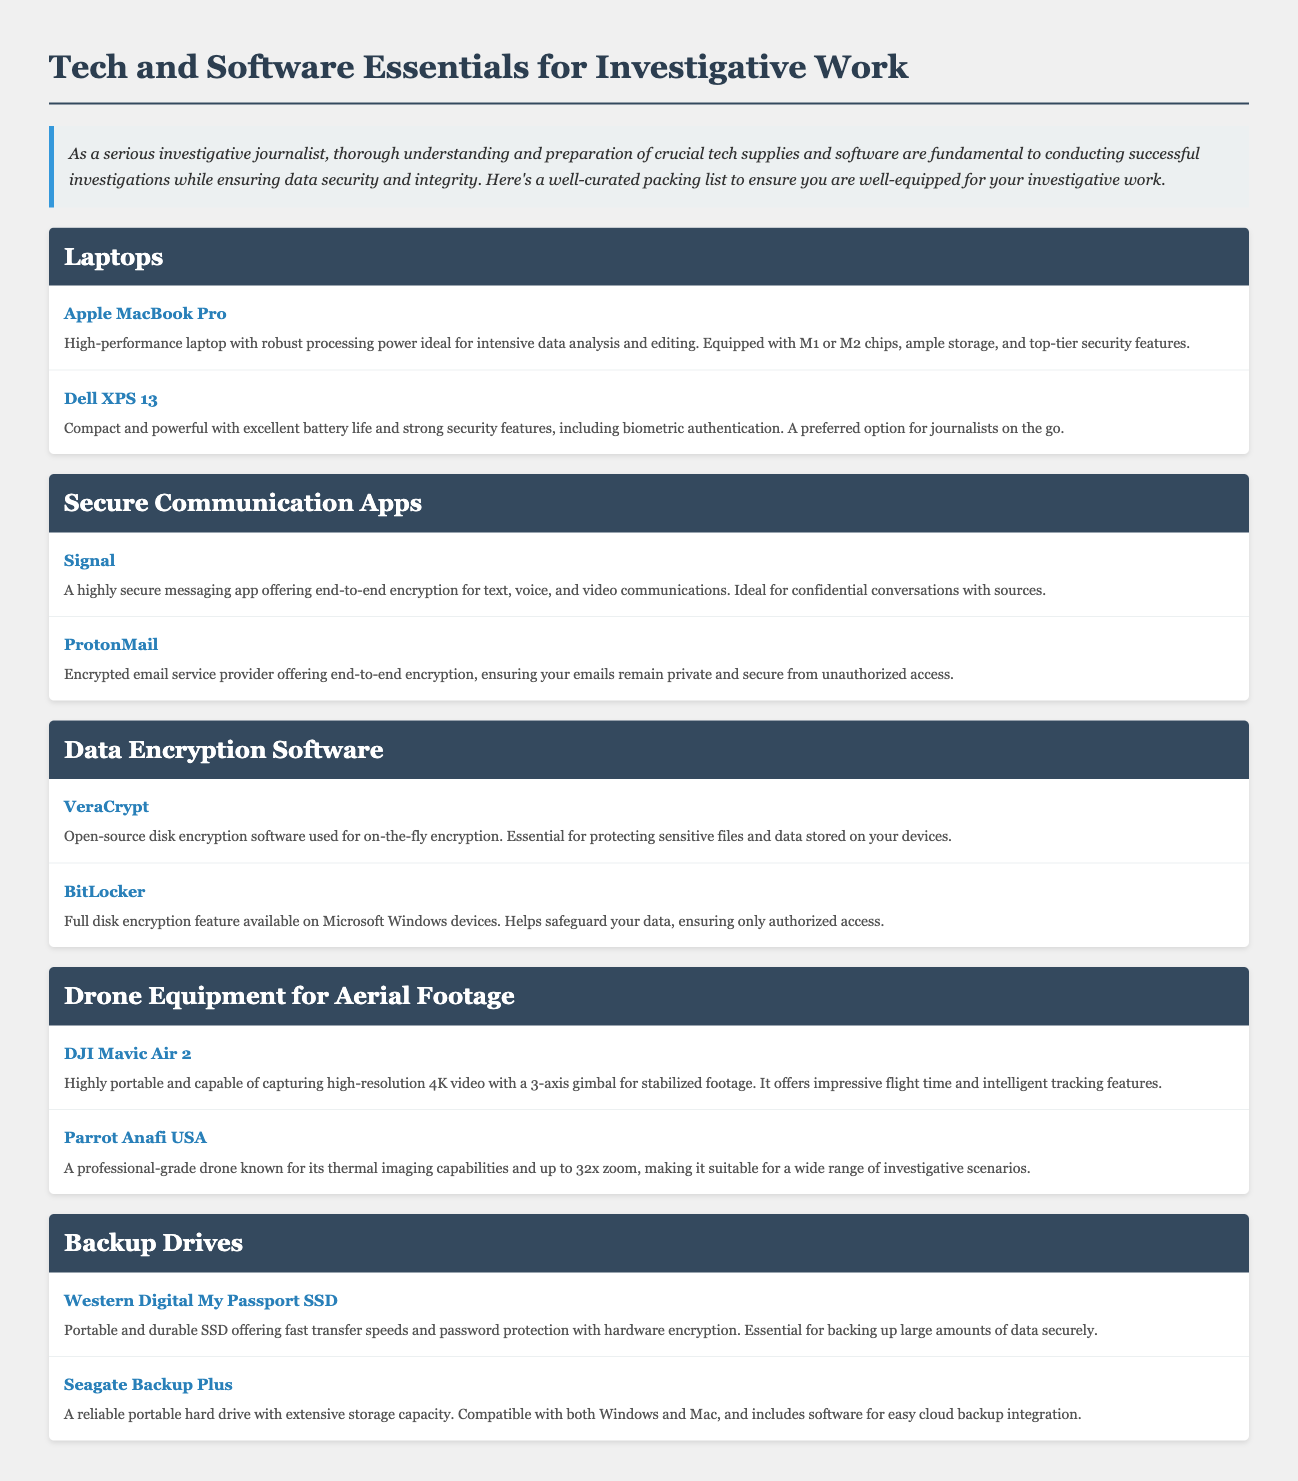What brand of laptops is highlighted for high-performance? The document mentions the Apple MacBook Pro as a high-performance laptop ideal for investigative work.
Answer: Apple MacBook Pro What feature is emphasized for the Dell XPS 13? The document highlights excellent battery life and strong security features, including biometric authentication.
Answer: Excellent battery life and strong security features Which secure communication app is recommended for encrypted email? The item description states ProtonMail as an encrypted email service provider offering end-to-end encryption.
Answer: ProtonMail What type of encryption does VeraCrypt provide? The document specifies VeraCrypt as an open-source disk encryption software used for on-the-fly encryption.
Answer: On-the-fly encryption What is the maximum zoom capability of the Parrot Anafi USA drone? The document states that the Parrot Anafi USA drone has up to 32x zoom, which is significant for various investigative scenarios.
Answer: 32x zoom How is the DJI Mavic Air 2 described in terms of video capability? The description mentions that the DJI Mavic Air 2 captures high-resolution 4K video with a 3-axis gimbal for stabilized footage.
Answer: High-resolution 4K video What is the primary function of the Western Digital My Passport SSD? The document states that it is essential for backing up large amounts of data securely.
Answer: Backing up large amounts of data securely Which brand of backup drive is compatible with both Windows and Mac? Seagate Backup Plus is mentioned as compatible with both Windows and Mac in the document.
Answer: Seagate Backup Plus 